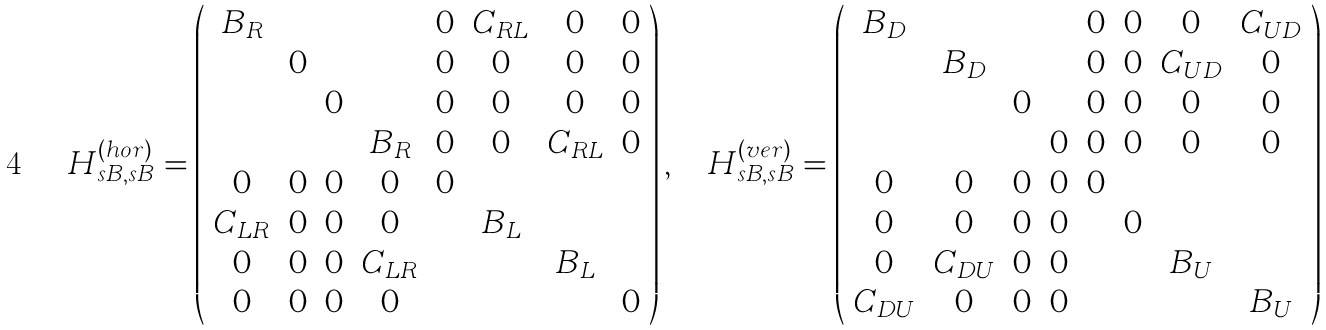<formula> <loc_0><loc_0><loc_500><loc_500>H ^ { ( h o r ) } _ { s B , s B } = \left ( \begin{array} { c c c c c c c c } B _ { R } & & & & 0 & C _ { R L } & 0 & 0 \\ & 0 & & & 0 & 0 & 0 & 0 \\ & & 0 & & 0 & 0 & 0 & 0 \\ & & & B _ { R } & 0 & 0 & C _ { R L } & 0 \\ 0 & 0 & 0 & 0 & 0 & & & \\ C _ { L R } & 0 & 0 & 0 & & B _ { L } & & \\ 0 & 0 & 0 & C _ { L R } & & & B _ { L } & \\ 0 & 0 & 0 & 0 & & & & 0 \end{array} \right ) , \quad H ^ { ( v e r ) } _ { s B , s B } = \left ( \begin{array} { c c c c c c c c } B _ { D } & & & & 0 & 0 & 0 & C _ { U D } \\ & B _ { D } & & & 0 & 0 & C _ { U D } & 0 \\ & & 0 & & 0 & 0 & 0 & 0 \\ & & & 0 & 0 & 0 & 0 & 0 \\ 0 & 0 & 0 & 0 & 0 & & & \\ 0 & 0 & 0 & 0 & & 0 & & \\ 0 & C _ { D U } & 0 & 0 & & & B _ { U } & \\ C _ { D U } & 0 & 0 & 0 & & & & B _ { U } \end{array} \right )</formula> 